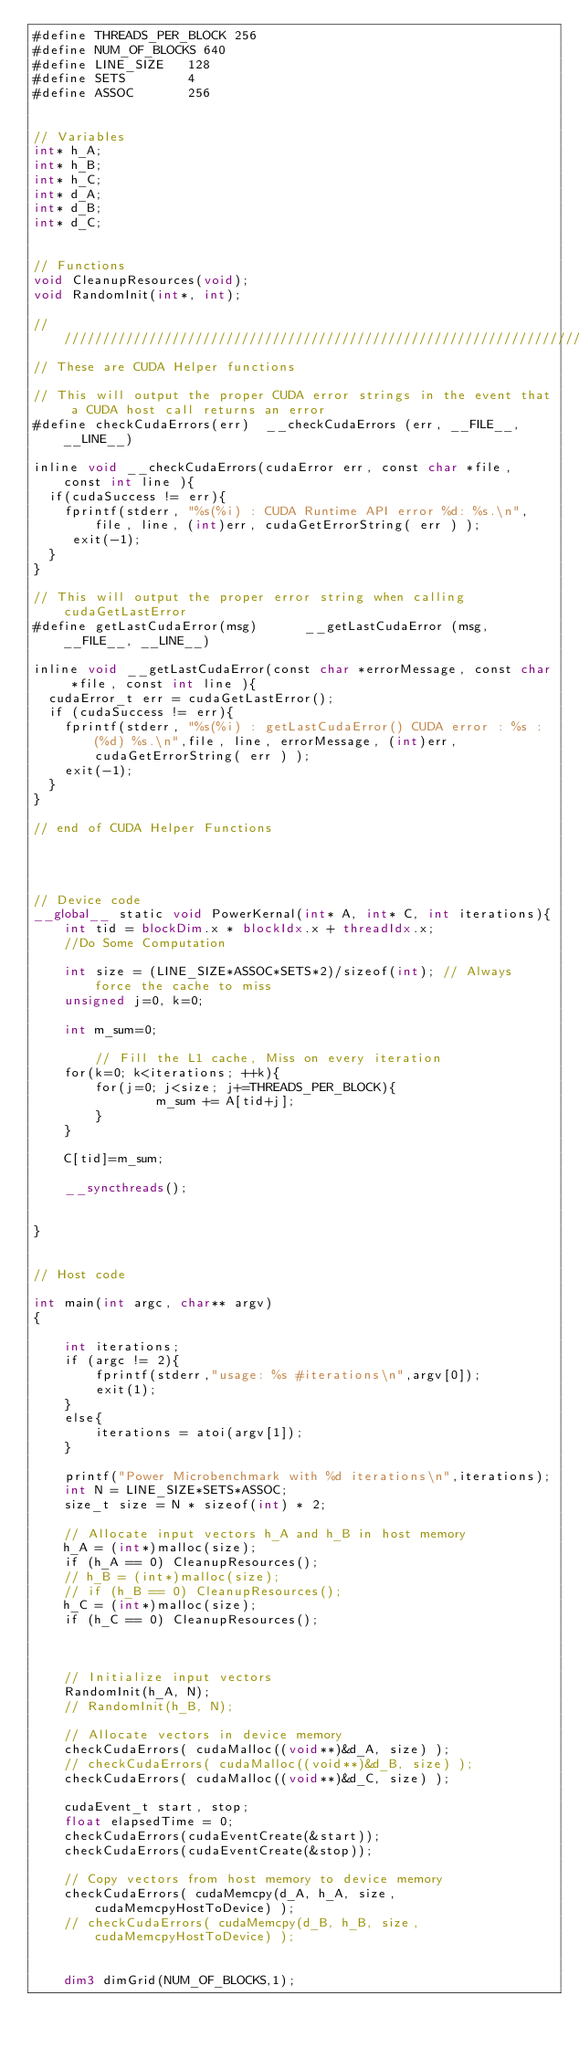Convert code to text. <code><loc_0><loc_0><loc_500><loc_500><_Cuda_>#define THREADS_PER_BLOCK 256
#define NUM_OF_BLOCKS 640
#define LINE_SIZE 	128
#define SETS		4
#define ASSOC		256


// Variables
int* h_A;
int* h_B;
int* h_C;
int* d_A;
int* d_B;
int* d_C;


// Functions
void CleanupResources(void);
void RandomInit(int*, int);

////////////////////////////////////////////////////////////////////////////////
// These are CUDA Helper functions

// This will output the proper CUDA error strings in the event that a CUDA host call returns an error
#define checkCudaErrors(err)  __checkCudaErrors (err, __FILE__, __LINE__)

inline void __checkCudaErrors(cudaError err, const char *file, const int line ){
  if(cudaSuccess != err){
	fprintf(stderr, "%s(%i) : CUDA Runtime API error %d: %s.\n",file, line, (int)err, cudaGetErrorString( err ) );
	 exit(-1);
  }
}

// This will output the proper error string when calling cudaGetLastError
#define getLastCudaError(msg)      __getLastCudaError (msg, __FILE__, __LINE__)

inline void __getLastCudaError(const char *errorMessage, const char *file, const int line ){
  cudaError_t err = cudaGetLastError();
  if (cudaSuccess != err){
	fprintf(stderr, "%s(%i) : getLastCudaError() CUDA error : %s : (%d) %s.\n",file, line, errorMessage, (int)err, cudaGetErrorString( err ) );
	exit(-1);
  }
}

// end of CUDA Helper Functions




// Device code
__global__ static void PowerKernal(int* A, int* C, int iterations){
    int tid = blockDim.x * blockIdx.x + threadIdx.x;
    //Do Some Computation

    int size = (LINE_SIZE*ASSOC*SETS*2)/sizeof(int); // Always force the cache to miss
    unsigned j=0, k=0;

    int m_sum=0;

		// Fill the L1 cache, Miss on every iteration
	for(k=0; k<iterations; ++k){
		for(j=0; j<size; j+=THREADS_PER_BLOCK){
				m_sum += A[tid+j];
		}
	}

	C[tid]=m_sum;

    __syncthreads();


}


// Host code

int main(int argc, char** argv) 
{

	int iterations;
	if (argc != 2){
		fprintf(stderr,"usage: %s #iterations\n",argv[0]);
		exit(1);
	}
	else{
		iterations = atoi(argv[1]);
	}

	printf("Power Microbenchmark with %d iterations\n",iterations);
	int N = LINE_SIZE*SETS*ASSOC;
	size_t size = N * sizeof(int) * 2;

	// Allocate input vectors h_A and h_B in host memory
	h_A = (int*)malloc(size);
	if (h_A == 0) CleanupResources();
	// h_B = (int*)malloc(size);
	// if (h_B == 0) CleanupResources();
	h_C = (int*)malloc(size);
	if (h_C == 0) CleanupResources();



	// Initialize input vectors
	RandomInit(h_A, N);
	// RandomInit(h_B, N);

	// Allocate vectors in device memory
	checkCudaErrors( cudaMalloc((void**)&d_A, size) );
	// checkCudaErrors( cudaMalloc((void**)&d_B, size) );
	checkCudaErrors( cudaMalloc((void**)&d_C, size) );

	cudaEvent_t start, stop;
	float elapsedTime = 0;
	checkCudaErrors(cudaEventCreate(&start));
	checkCudaErrors(cudaEventCreate(&stop));

	// Copy vectors from host memory to device memory
	checkCudaErrors( cudaMemcpy(d_A, h_A, size, cudaMemcpyHostToDevice) );
	// checkCudaErrors( cudaMemcpy(d_B, h_B, size, cudaMemcpyHostToDevice) );


	dim3 dimGrid(NUM_OF_BLOCKS,1);</code> 